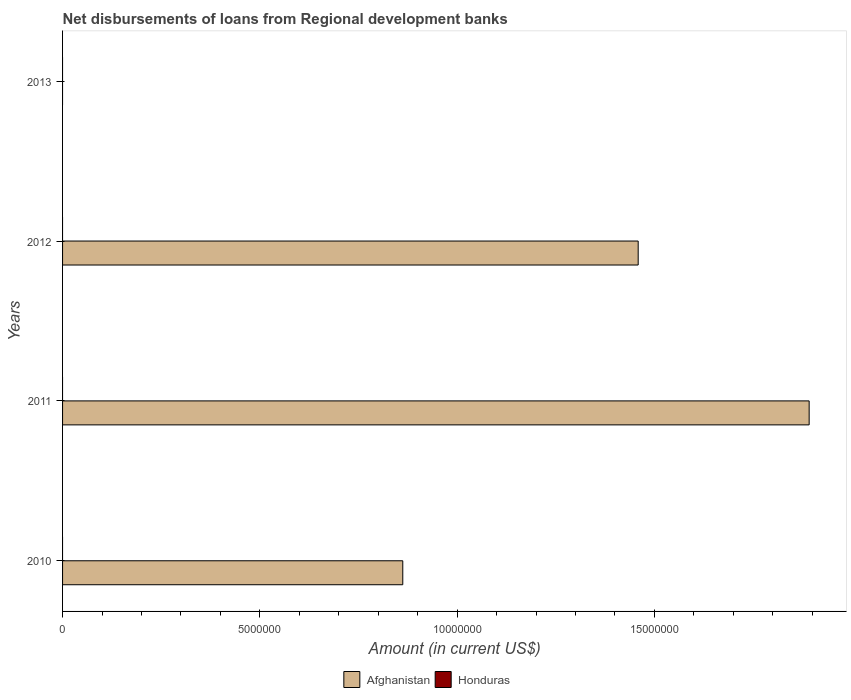How many different coloured bars are there?
Ensure brevity in your answer.  1. Are the number of bars per tick equal to the number of legend labels?
Your answer should be very brief. No. How many bars are there on the 4th tick from the top?
Make the answer very short. 1. How many bars are there on the 3rd tick from the bottom?
Your response must be concise. 1. What is the label of the 1st group of bars from the top?
Offer a terse response. 2013. In how many cases, is the number of bars for a given year not equal to the number of legend labels?
Keep it short and to the point. 4. What is the amount of disbursements of loans from regional development banks in Afghanistan in 2010?
Your answer should be compact. 8.62e+06. Across all years, what is the maximum amount of disbursements of loans from regional development banks in Afghanistan?
Make the answer very short. 1.89e+07. Across all years, what is the minimum amount of disbursements of loans from regional development banks in Honduras?
Offer a terse response. 0. What is the total amount of disbursements of loans from regional development banks in Afghanistan in the graph?
Your answer should be compact. 4.21e+07. What is the difference between the amount of disbursements of loans from regional development banks in Afghanistan in 2010 and that in 2011?
Ensure brevity in your answer.  -1.03e+07. What is the difference between the amount of disbursements of loans from regional development banks in Afghanistan in 2010 and the amount of disbursements of loans from regional development banks in Honduras in 2011?
Offer a terse response. 8.62e+06. What is the average amount of disbursements of loans from regional development banks in Afghanistan per year?
Give a very brief answer. 1.05e+07. What is the ratio of the amount of disbursements of loans from regional development banks in Afghanistan in 2011 to that in 2012?
Provide a succinct answer. 1.3. What is the difference between the highest and the second highest amount of disbursements of loans from regional development banks in Afghanistan?
Ensure brevity in your answer.  4.33e+06. What is the difference between the highest and the lowest amount of disbursements of loans from regional development banks in Afghanistan?
Provide a succinct answer. 1.89e+07. Is the sum of the amount of disbursements of loans from regional development banks in Afghanistan in 2011 and 2012 greater than the maximum amount of disbursements of loans from regional development banks in Honduras across all years?
Keep it short and to the point. Yes. How many bars are there?
Provide a succinct answer. 3. How many years are there in the graph?
Give a very brief answer. 4. Are the values on the major ticks of X-axis written in scientific E-notation?
Offer a terse response. No. How are the legend labels stacked?
Your response must be concise. Horizontal. What is the title of the graph?
Your answer should be very brief. Net disbursements of loans from Regional development banks. Does "Middle East & North Africa (developing only)" appear as one of the legend labels in the graph?
Your answer should be compact. No. What is the Amount (in current US$) of Afghanistan in 2010?
Give a very brief answer. 8.62e+06. What is the Amount (in current US$) in Honduras in 2010?
Keep it short and to the point. 0. What is the Amount (in current US$) of Afghanistan in 2011?
Your answer should be compact. 1.89e+07. What is the Amount (in current US$) in Honduras in 2011?
Offer a terse response. 0. What is the Amount (in current US$) in Afghanistan in 2012?
Your answer should be compact. 1.46e+07. Across all years, what is the maximum Amount (in current US$) of Afghanistan?
Give a very brief answer. 1.89e+07. What is the total Amount (in current US$) of Afghanistan in the graph?
Give a very brief answer. 4.21e+07. What is the difference between the Amount (in current US$) in Afghanistan in 2010 and that in 2011?
Offer a very short reply. -1.03e+07. What is the difference between the Amount (in current US$) in Afghanistan in 2010 and that in 2012?
Offer a terse response. -5.97e+06. What is the difference between the Amount (in current US$) in Afghanistan in 2011 and that in 2012?
Make the answer very short. 4.33e+06. What is the average Amount (in current US$) of Afghanistan per year?
Keep it short and to the point. 1.05e+07. What is the ratio of the Amount (in current US$) in Afghanistan in 2010 to that in 2011?
Your response must be concise. 0.46. What is the ratio of the Amount (in current US$) of Afghanistan in 2010 to that in 2012?
Make the answer very short. 0.59. What is the ratio of the Amount (in current US$) of Afghanistan in 2011 to that in 2012?
Make the answer very short. 1.3. What is the difference between the highest and the second highest Amount (in current US$) of Afghanistan?
Keep it short and to the point. 4.33e+06. What is the difference between the highest and the lowest Amount (in current US$) of Afghanistan?
Your answer should be very brief. 1.89e+07. 